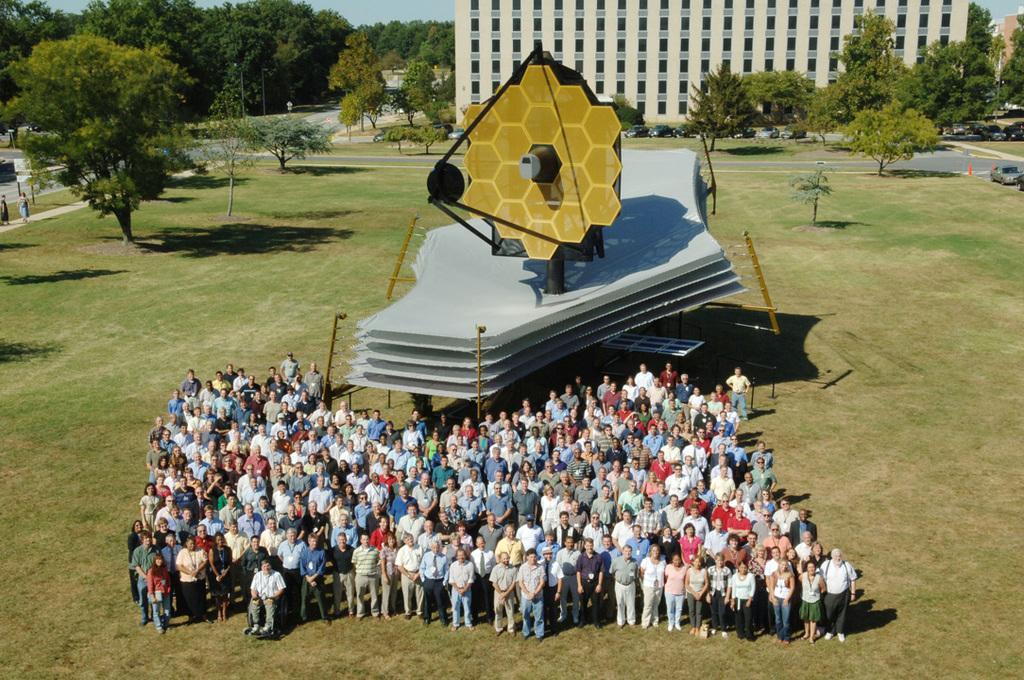In one or two sentences, can you explain what this image depicts? This image is clicked outside. There is a building at the top. There are trees at the top. There are so many people standing in the middle. There is a car on the right side. There are some people walking on the left side. 